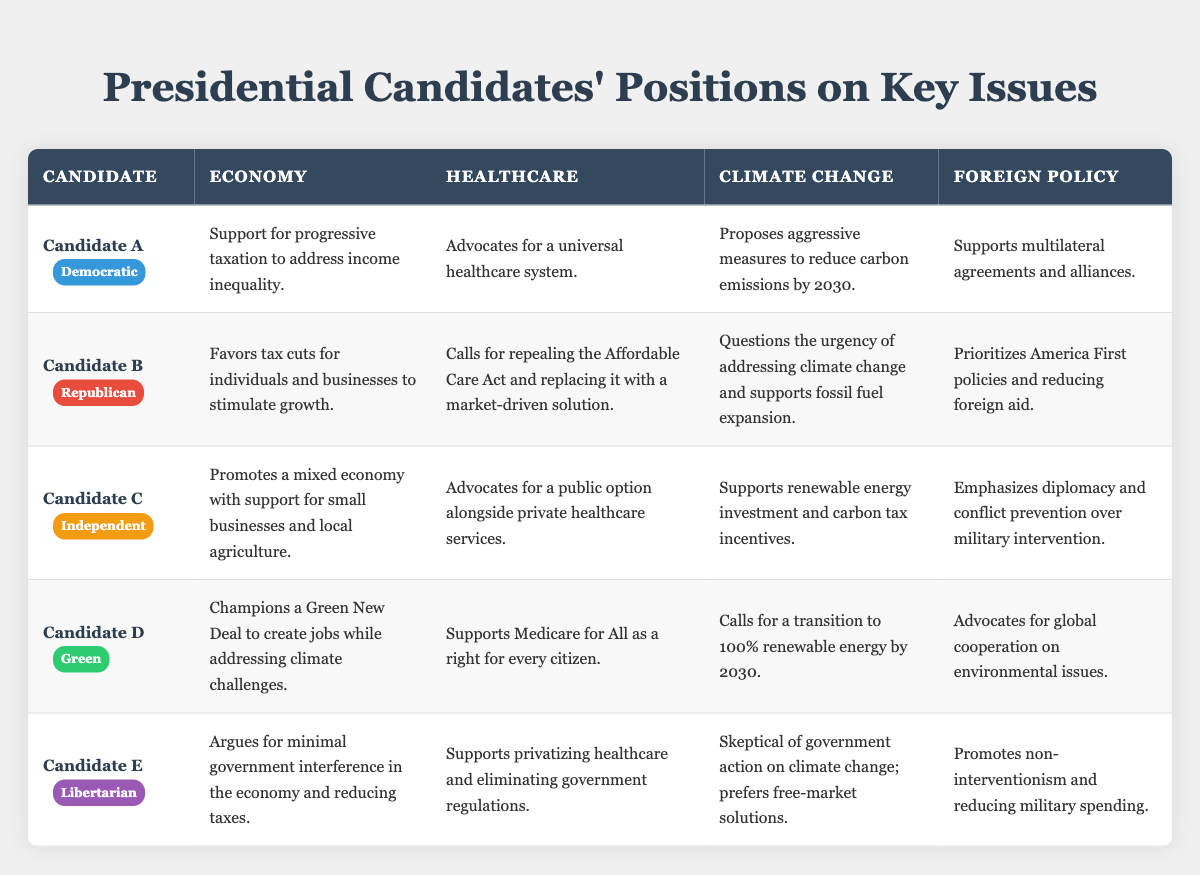What is Candidate A's stance on climate change? Candidate A proposes aggressive measures to reduce carbon emissions by 2030, as stated in the table.
Answer: Aggressive measures to reduce carbon emissions by 2030 What party does Candidate B belong to? According to the table, Candidate B is identified under the Republican party.
Answer: Republican Which candidate supports Medicare for All? The table shows that Candidate D supports Medicare for All as a right for every citizen.
Answer: Candidate D How do Candidate C's healthcare proposals differ from Candidate B's? Candidate C advocates for a public option alongside private healthcare services, while Candidate B calls for repealing the Affordable Care Act and replacing it with a market-driven solution. The difference lies in the support for a public option versus a complete repeal.
Answer: Candidate C supports a public option; Candidate B advocates for repeal Which candidates support measures to address climate change? Candidates A, C, and D support measures for climate change. Candidate A proposes aggressive measures, Candidate C supports renewable energy investments, and Candidate D calls for a transition to 100% renewable energy by 2030.
Answer: Candidates A, C, and D Is there a candidate who argues for minimal government interference in the economy? Yes, Candidate E argues for minimal government interference and reducing taxes, as specified in the table.
Answer: Yes, Candidate E Which candidate's economic policy includes support for a Green New Deal? Candidate D champions a Green New Deal to create jobs and address climate challenges, according to the table.
Answer: Candidate D Compare the foreign policy approaches of Candidate B and Candidate D. Candidate B prioritizes America First policies and reducing foreign aid, while Candidate D advocates for global cooperation on environmental issues. The contrast highlights a unilateral versus multilateral strategy.
Answer: Candidate B focuses on America First; Candidate D emphasizes global cooperation Which candidate expresses skepticism towards government action on climate change? The table indicates that Candidate E is skeptical of government action on climate change and prefers free-market solutions.
Answer: Candidate E What are the main healthcare proposals of the Independent candidate? Candidate C's main healthcare proposal is advocating for a public option alongside private healthcare services, as stated in the table.
Answer: A public option alongside private healthcare services 